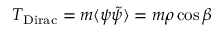<formula> <loc_0><loc_0><loc_500><loc_500>T _ { D i r a c } = m \langle \psi \tilde { \psi } \rangle = m \rho \cos \beta</formula> 